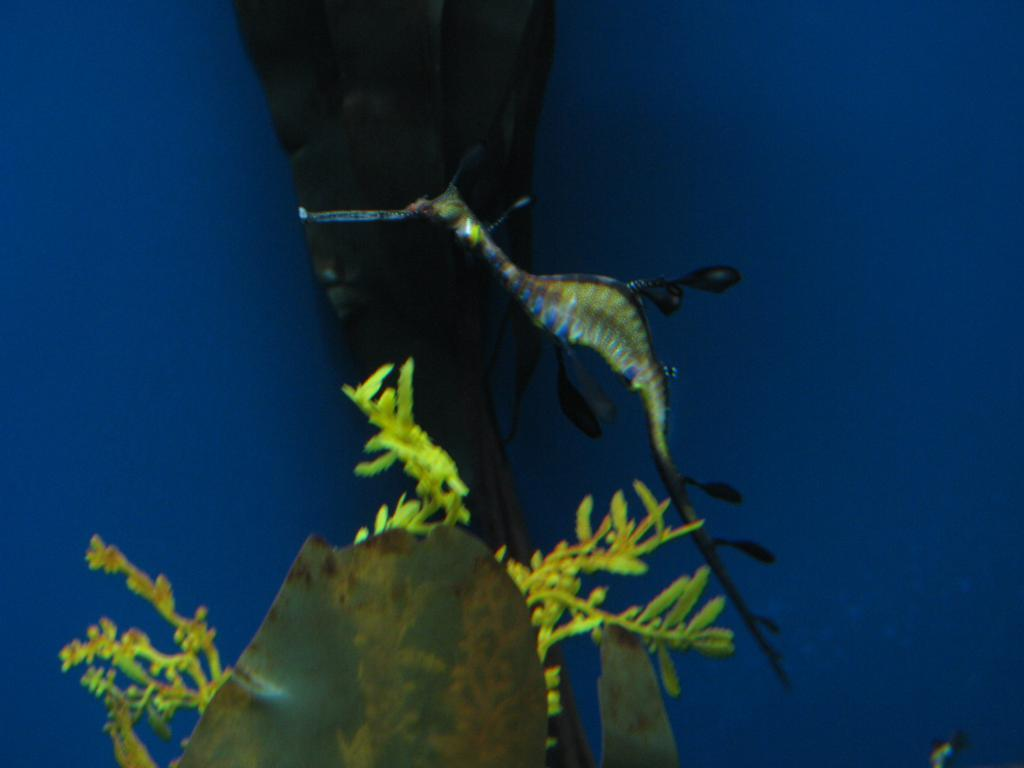What type of creature is in the image? There is a sea animal in the image. What other living organism is present in the image? There is a plant in the image. Can you describe any other objects in the image? There are a few objects in the image. What color is the background of the image? The background of the image is blue. What type of glove is being worn by the goldfish in the image? There is no glove present in the image, and the sea animal is not a goldfish. 